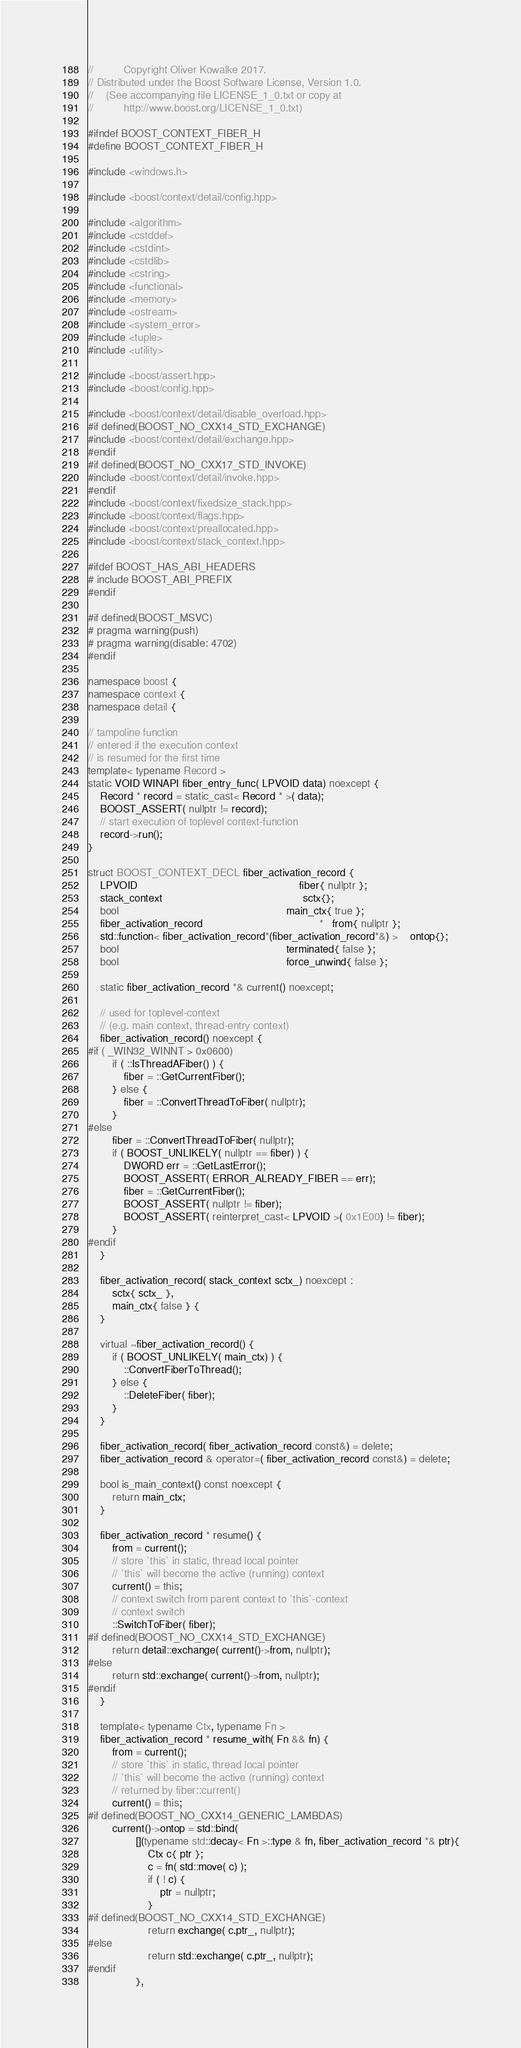Convert code to text. <code><loc_0><loc_0><loc_500><loc_500><_C++_>
//          Copyright Oliver Kowalke 2017.
// Distributed under the Boost Software License, Version 1.0.
//    (See accompanying file LICENSE_1_0.txt or copy at
//          http://www.boost.org/LICENSE_1_0.txt)

#ifndef BOOST_CONTEXT_FIBER_H
#define BOOST_CONTEXT_FIBER_H

#include <windows.h>

#include <boost/context/detail/config.hpp>

#include <algorithm>
#include <cstddef>
#include <cstdint>
#include <cstdlib>
#include <cstring>
#include <functional>
#include <memory>
#include <ostream>
#include <system_error>
#include <tuple>
#include <utility>

#include <boost/assert.hpp>
#include <boost/config.hpp>

#include <boost/context/detail/disable_overload.hpp>
#if defined(BOOST_NO_CXX14_STD_EXCHANGE)
#include <boost/context/detail/exchange.hpp>
#endif
#if defined(BOOST_NO_CXX17_STD_INVOKE)
#include <boost/context/detail/invoke.hpp>
#endif
#include <boost/context/fixedsize_stack.hpp>
#include <boost/context/flags.hpp>
#include <boost/context/preallocated.hpp>
#include <boost/context/stack_context.hpp>

#ifdef BOOST_HAS_ABI_HEADERS
# include BOOST_ABI_PREFIX
#endif

#if defined(BOOST_MSVC)
# pragma warning(push)
# pragma warning(disable: 4702)
#endif

namespace boost {
namespace context {
namespace detail {

// tampoline function
// entered if the execution context
// is resumed for the first time
template< typename Record >
static VOID WINAPI fiber_entry_func( LPVOID data) noexcept {
    Record * record = static_cast< Record * >( data);
    BOOST_ASSERT( nullptr != record);
    // start execution of toplevel context-function
    record->run();
}

struct BOOST_CONTEXT_DECL fiber_activation_record {
    LPVOID                                                      fiber{ nullptr };
    stack_context                                               sctx{};
    bool                                                        main_ctx{ true };
    fiber_activation_record                                       *   from{ nullptr };
    std::function< fiber_activation_record*(fiber_activation_record*&) >    ontop{};
    bool                                                        terminated{ false };
    bool                                                        force_unwind{ false };

    static fiber_activation_record *& current() noexcept;

    // used for toplevel-context
    // (e.g. main context, thread-entry context)
    fiber_activation_record() noexcept {
#if ( _WIN32_WINNT > 0x0600)
        if ( ::IsThreadAFiber() ) {
            fiber = ::GetCurrentFiber();
        } else {
            fiber = ::ConvertThreadToFiber( nullptr);
        }
#else
        fiber = ::ConvertThreadToFiber( nullptr);
        if ( BOOST_UNLIKELY( nullptr == fiber) ) {
            DWORD err = ::GetLastError();
            BOOST_ASSERT( ERROR_ALREADY_FIBER == err);
            fiber = ::GetCurrentFiber(); 
            BOOST_ASSERT( nullptr != fiber);
            BOOST_ASSERT( reinterpret_cast< LPVOID >( 0x1E00) != fiber);
        }
#endif
    }

    fiber_activation_record( stack_context sctx_) noexcept :
        sctx{ sctx_ },
        main_ctx{ false } {
    } 

    virtual ~fiber_activation_record() {
        if ( BOOST_UNLIKELY( main_ctx) ) {
            ::ConvertFiberToThread();
        } else {
            ::DeleteFiber( fiber);
        }
    }

    fiber_activation_record( fiber_activation_record const&) = delete;
    fiber_activation_record & operator=( fiber_activation_record const&) = delete;

    bool is_main_context() const noexcept {
        return main_ctx;
    }

    fiber_activation_record * resume() {
        from = current();
        // store `this` in static, thread local pointer
        // `this` will become the active (running) context
        current() = this;
        // context switch from parent context to `this`-context
        // context switch
        ::SwitchToFiber( fiber);
#if defined(BOOST_NO_CXX14_STD_EXCHANGE)
        return detail::exchange( current()->from, nullptr);
#else
        return std::exchange( current()->from, nullptr);
#endif
    }

    template< typename Ctx, typename Fn >
    fiber_activation_record * resume_with( Fn && fn) {
        from = current();
        // store `this` in static, thread local pointer
        // `this` will become the active (running) context
        // returned by fiber::current()
        current() = this;
#if defined(BOOST_NO_CXX14_GENERIC_LAMBDAS)
        current()->ontop = std::bind(
                [](typename std::decay< Fn >::type & fn, fiber_activation_record *& ptr){
                    Ctx c{ ptr };
                    c = fn( std::move( c) );
                    if ( ! c) {
                        ptr = nullptr;
                    }
#if defined(BOOST_NO_CXX14_STD_EXCHANGE)
                    return exchange( c.ptr_, nullptr);
#else
                    return std::exchange( c.ptr_, nullptr);
#endif
                },</code> 